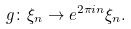<formula> <loc_0><loc_0><loc_500><loc_500>g \colon \xi _ { n } \to e ^ { 2 \pi i n } \xi _ { n } .</formula> 